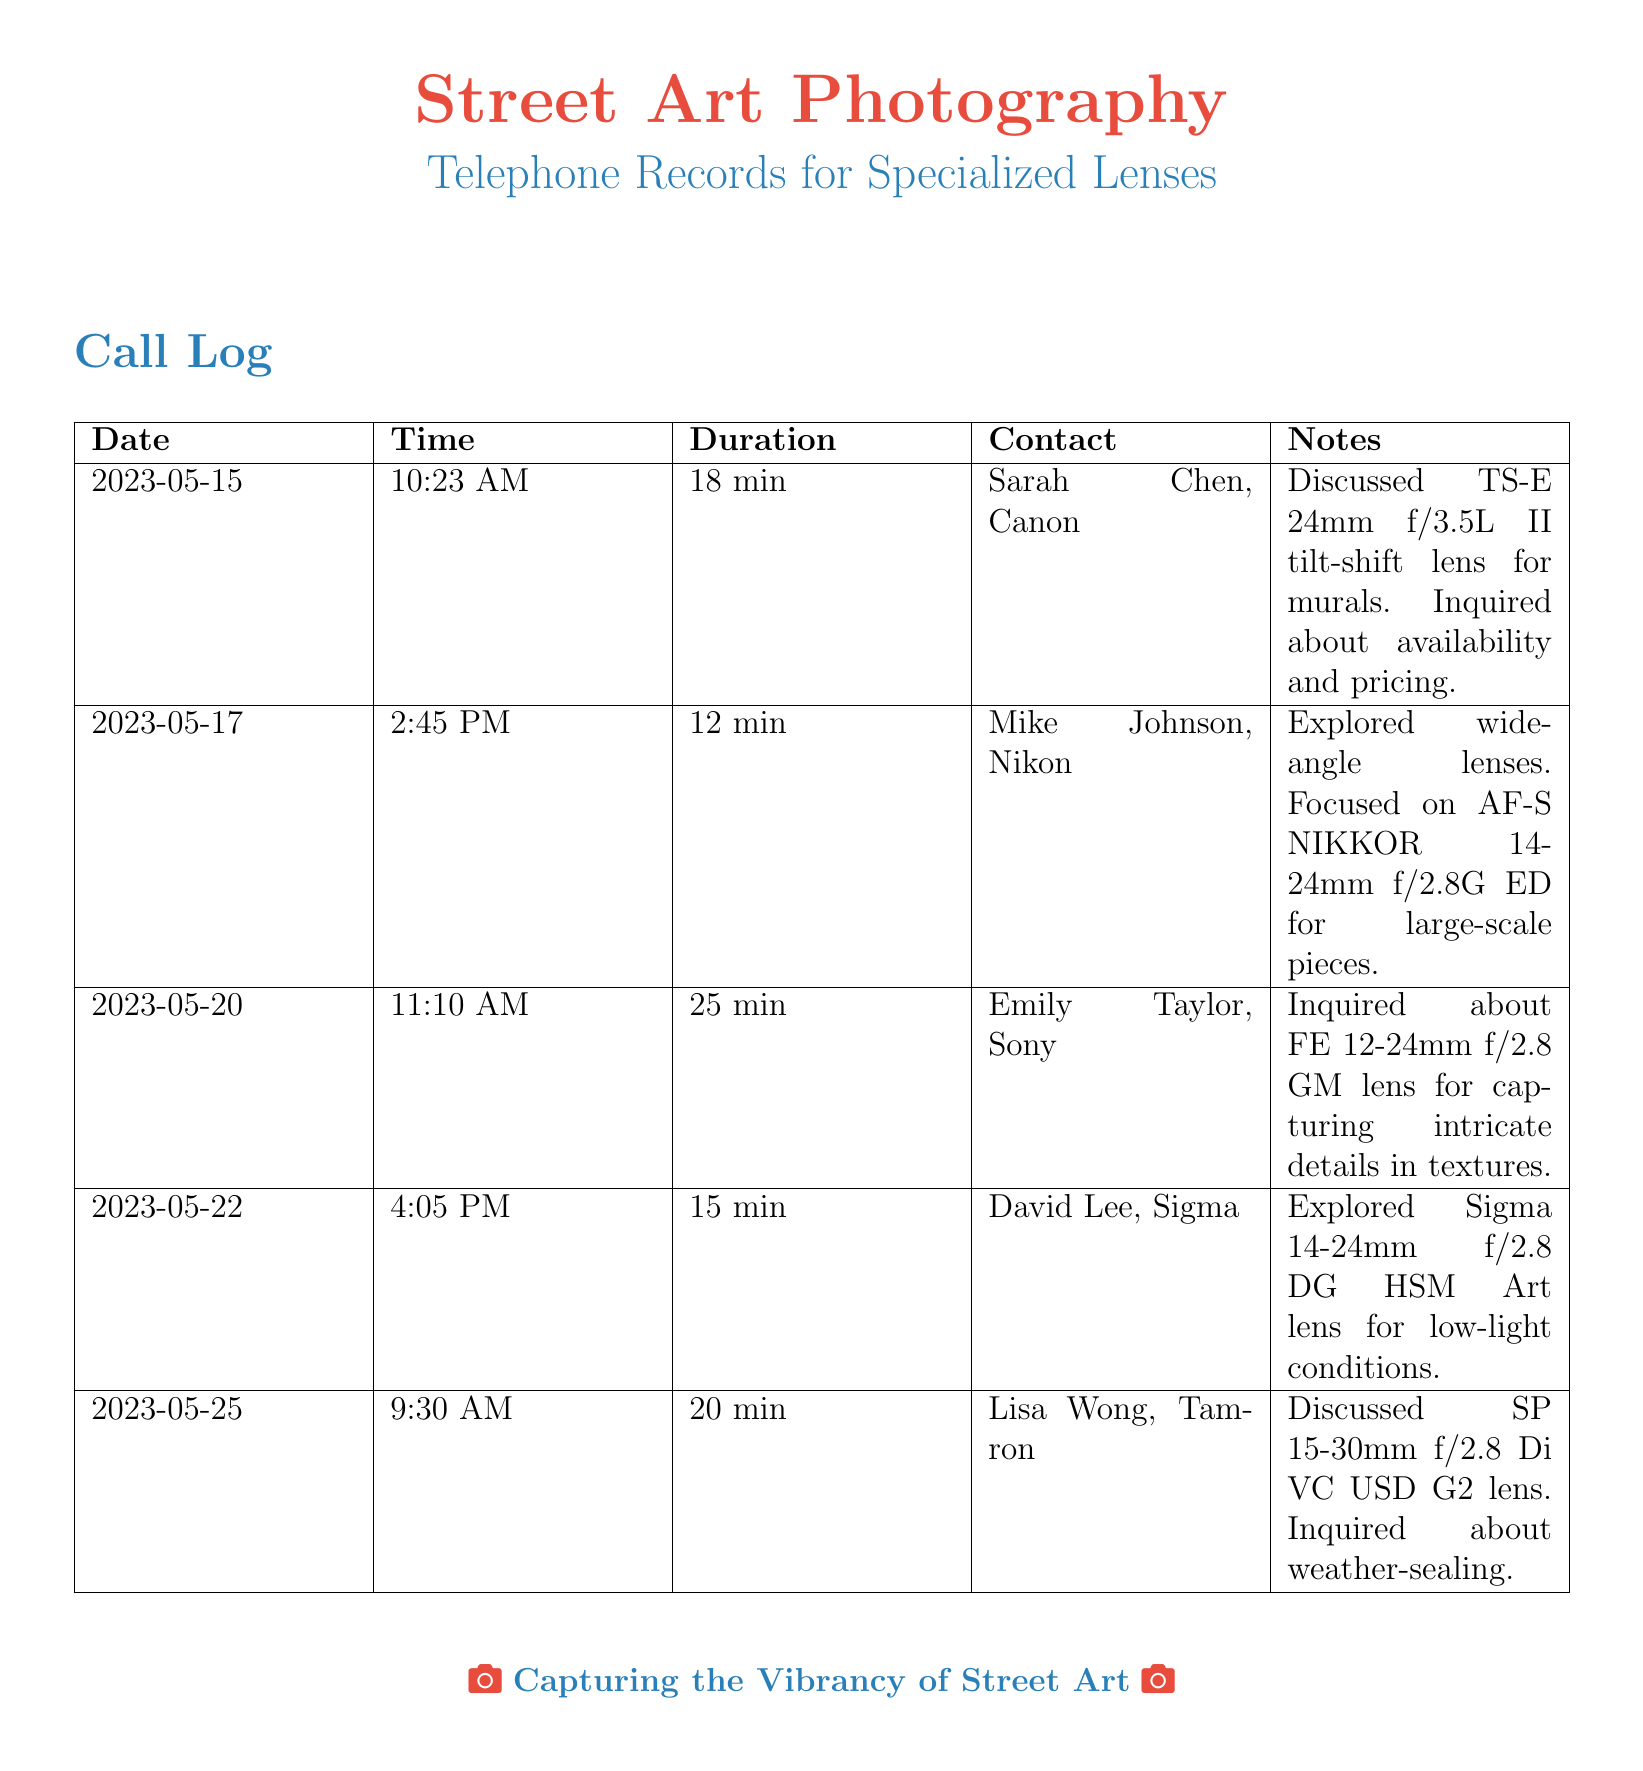What is the date of the first call? The first call recorded in the document is on May 15, 2023.
Answer: May 15, 2023 Who was the contact for the last call? The last call in the table was made to Lisa Wong from Tamron.
Answer: Lisa Wong, Tamron What is the duration of the second call? The second call lasted for 12 minutes, as shown in the duration column.
Answer: 12 min Which lens was discussed during the call with Emily Taylor? The lens mentioned in the call with Emily Taylor is the FE 12-24mm f/2.8 GM.
Answer: FE 12-24mm f/2.8 GM How many contacts are listed in the document? The document lists five different contacts in the call log.
Answer: 5 What is the primary focus of the conversations recorded? The conversations revolve around specialized lenses for capturing street art effectively.
Answer: Specialized lenses for capturing street art What was inquired about the SP 15-30mm f/2.8 lens? During the call, inquiring concerned its weather-sealing features.
Answer: Weather-sealing Which lens is associated with low-light conditions? The Sigma 14-24mm f/2.8 DG HSM Art lens is explored for low-light conditions.
Answer: Sigma 14-24mm f/2.8 DG HSM Art 